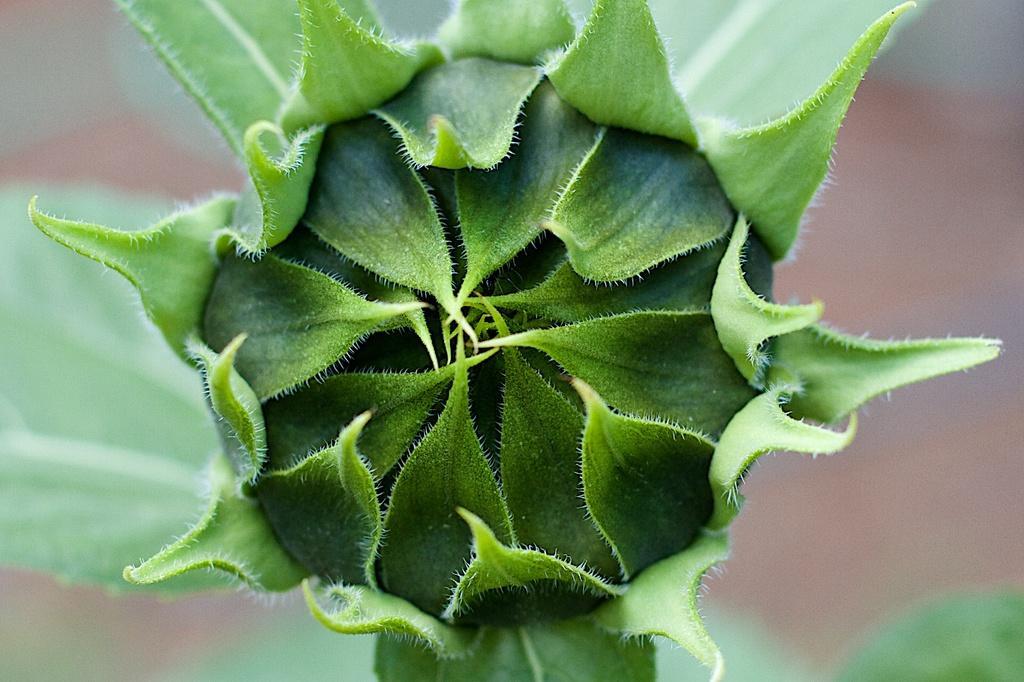Can you describe this image briefly? In the picture we can see a green color plant with a bud covered with leaves. 